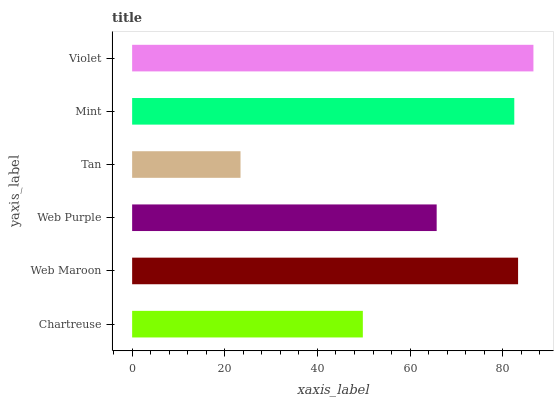Is Tan the minimum?
Answer yes or no. Yes. Is Violet the maximum?
Answer yes or no. Yes. Is Web Maroon the minimum?
Answer yes or no. No. Is Web Maroon the maximum?
Answer yes or no. No. Is Web Maroon greater than Chartreuse?
Answer yes or no. Yes. Is Chartreuse less than Web Maroon?
Answer yes or no. Yes. Is Chartreuse greater than Web Maroon?
Answer yes or no. No. Is Web Maroon less than Chartreuse?
Answer yes or no. No. Is Mint the high median?
Answer yes or no. Yes. Is Web Purple the low median?
Answer yes or no. Yes. Is Violet the high median?
Answer yes or no. No. Is Mint the low median?
Answer yes or no. No. 